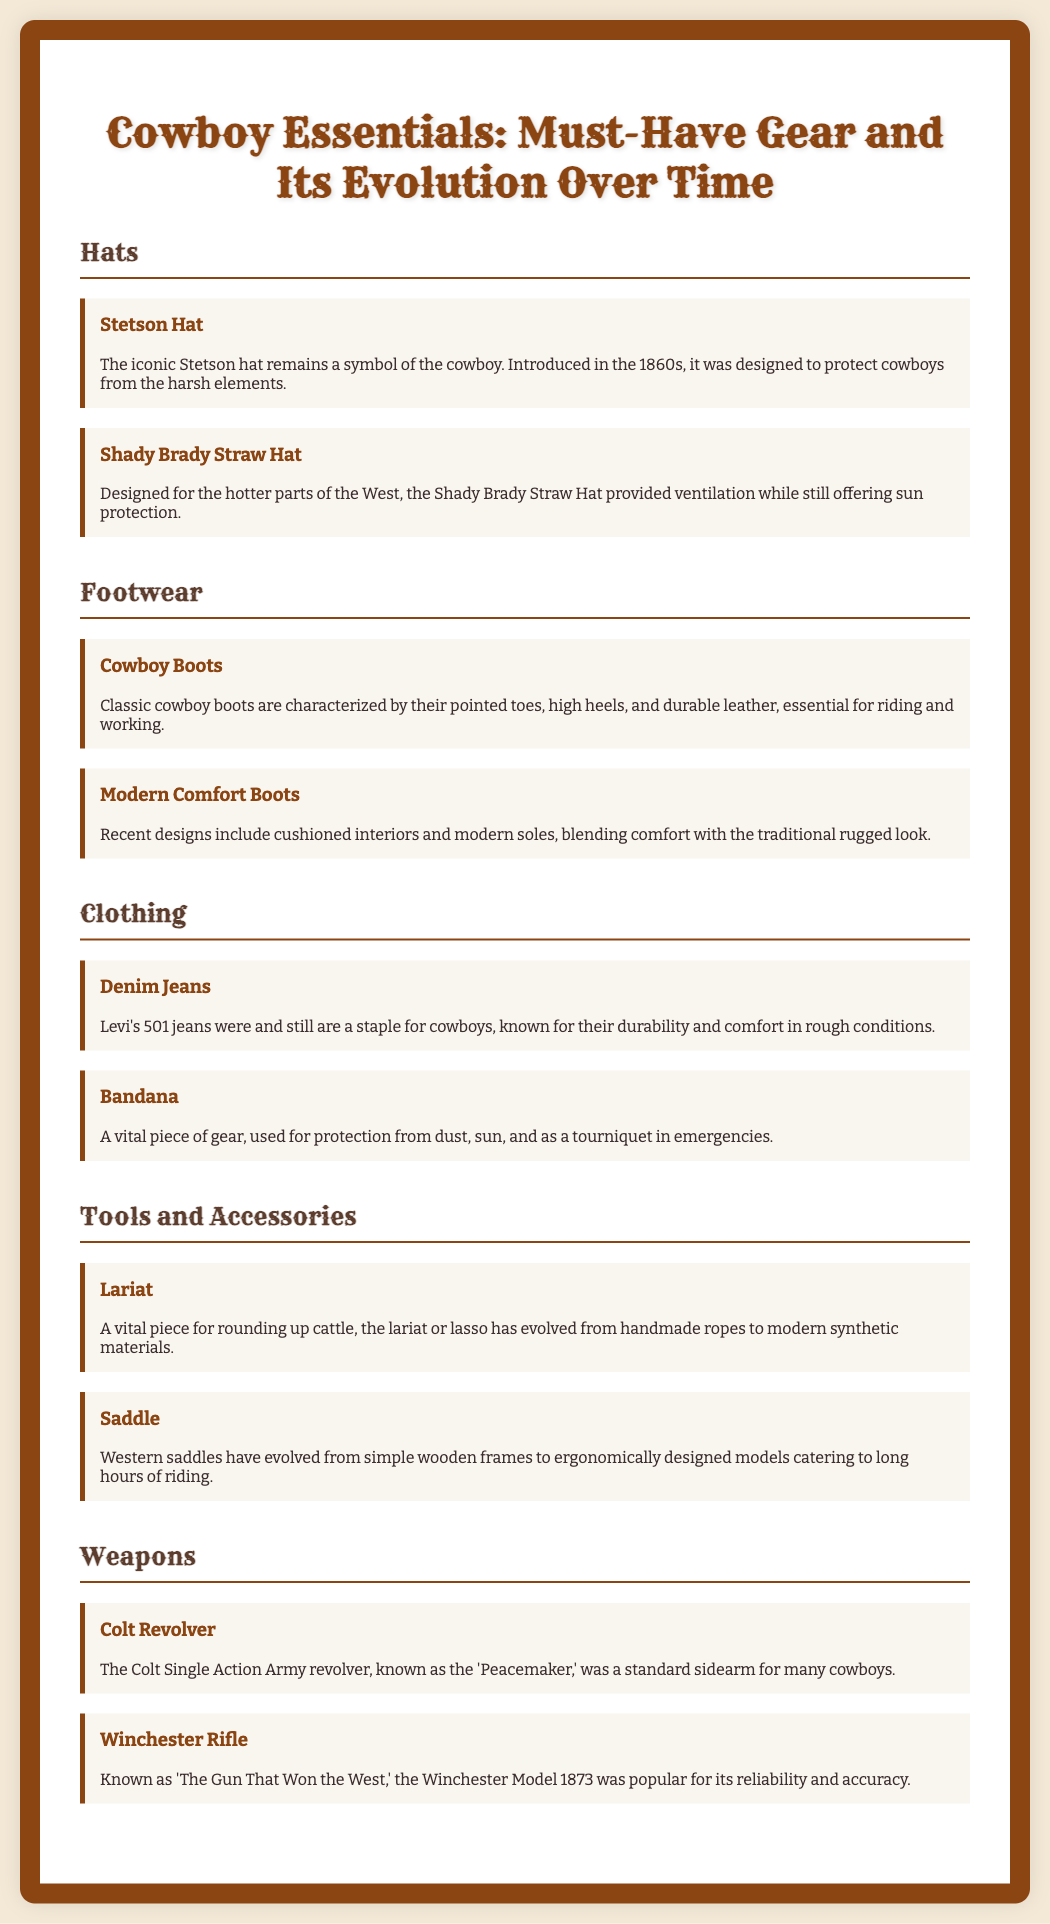What type of hat remains a symbol of the cowboy? The document states that the Stetson hat is the iconic symbol of the cowboy.
Answer: Stetson Hat What are cowboy boots characterized by? The document mentions that cowboy boots are characterized by pointed toes, high heels, and durable leather.
Answer: Pointed toes, high heels, durable leather When were Levi's 501 jeans introduced? The document does not specify a date for Levi's 501 jeans, but they are referenced as a staple known for durability.
Answer: Not specified What is the primary use of a lariat? According to the document, the lariat is a vital piece for rounding up cattle.
Answer: Rounding up cattle Which revolver is known as the 'Peacemaker'? The document identifies the Colt Single Action Army revolver as the 'Peacemaker.'
Answer: Colt Revolver What material have modern lariats evolved to? The document indicates that modern lariats have evolved from handmade ropes to synthetic materials.
Answer: Synthetic materials What is a vital piece of gear used for sun protection? The bandana is highlighted in the document as vital for protection from the sun.
Answer: Bandana What does the document say about the evolution of saddles? The document states that Western saddles have evolved from simple wooden frames to ergonomically designed models.
Answer: Ergonomically designed models Which rifle is referred to as 'The Gun That Won the West'? The document refers to the Winchester Model 1873 as 'The Gun That Won the West.'
Answer: Winchester Model 1873 